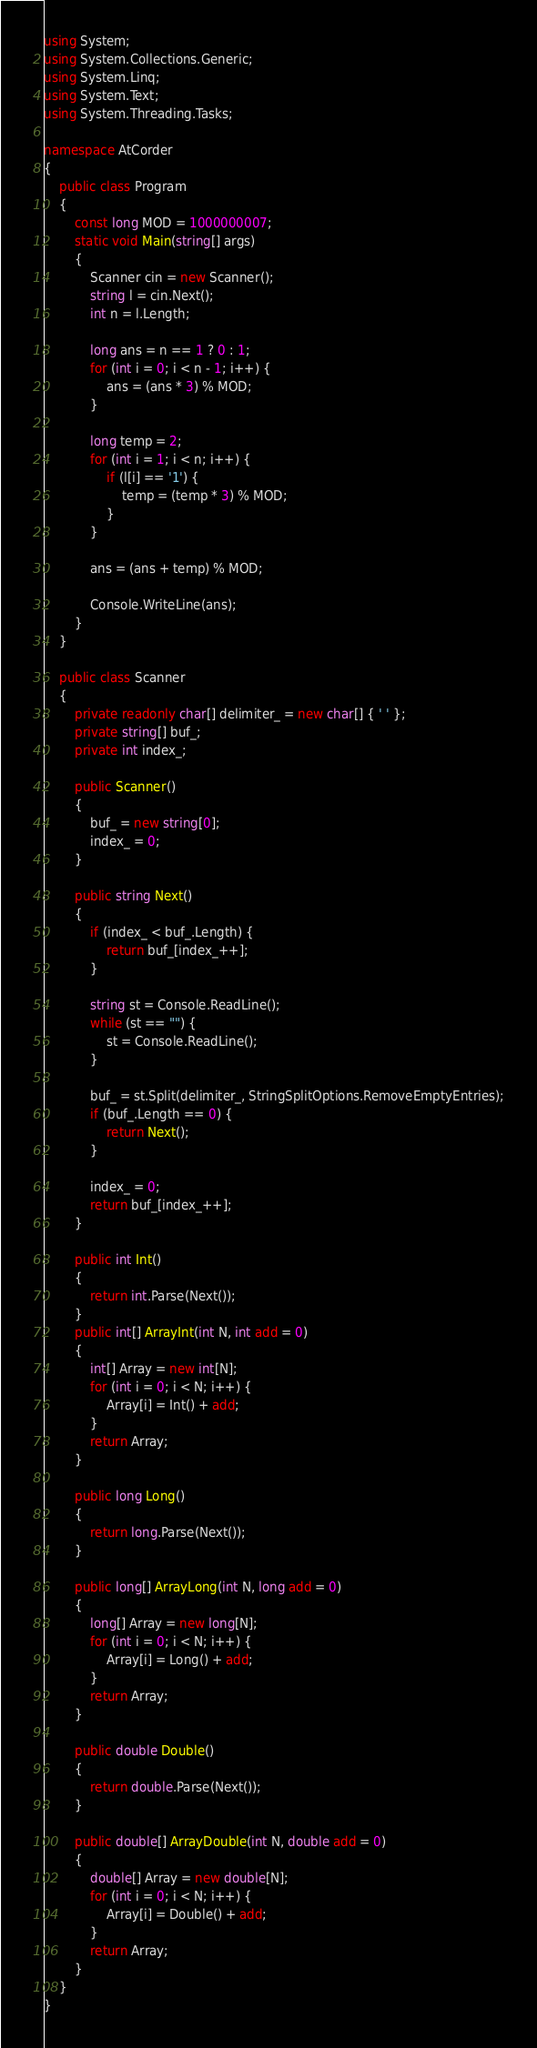<code> <loc_0><loc_0><loc_500><loc_500><_C#_>using System;
using System.Collections.Generic;
using System.Linq;
using System.Text;
using System.Threading.Tasks;

namespace AtCorder
{
	public class Program
	{
		const long MOD = 1000000007;
		static void Main(string[] args)
		{
			Scanner cin = new Scanner();
			string l = cin.Next();
			int n = l.Length;

			long ans = n == 1 ? 0 : 1;
			for (int i = 0; i < n - 1; i++) {
				ans = (ans * 3) % MOD;
			}

			long temp = 2;
			for (int i = 1; i < n; i++) {
				if (l[i] == '1') {
					temp = (temp * 3) % MOD;
				} 
			}

			ans = (ans + temp) % MOD;

			Console.WriteLine(ans);
		}
	}

	public class Scanner
	{
		private readonly char[] delimiter_ = new char[] { ' ' };
		private string[] buf_;
		private int index_;
		
		public Scanner()
		{
			buf_ = new string[0];
			index_ = 0;
		}

		public string Next()
		{
			if (index_ < buf_.Length) {
				return buf_[index_++];
			}

			string st = Console.ReadLine();
			while (st == "") {
				st = Console.ReadLine();
			}

			buf_ = st.Split(delimiter_, StringSplitOptions.RemoveEmptyEntries);
			if (buf_.Length == 0) {
				return Next();
			}

			index_ = 0;
			return buf_[index_++];
		}

		public int Int()
		{
			return int.Parse(Next());
		}
		public int[] ArrayInt(int N, int add = 0)
		{
			int[] Array = new int[N];
			for (int i = 0; i < N; i++) {
				Array[i] = Int() + add;
			}
			return Array;
		}

		public long Long()
		{
			return long.Parse(Next());
		}

		public long[] ArrayLong(int N, long add = 0)
		{
			long[] Array = new long[N];
			for (int i = 0; i < N; i++) {
				Array[i] = Long() + add;
			}
			return Array;
		}

		public double Double()
		{
			return double.Parse(Next());
		}

		public double[] ArrayDouble(int N, double add = 0)
		{
			double[] Array = new double[N];
			for (int i = 0; i < N; i++) {
				Array[i] = Double() + add;
			}
			return Array;
		}
	}
}
</code> 